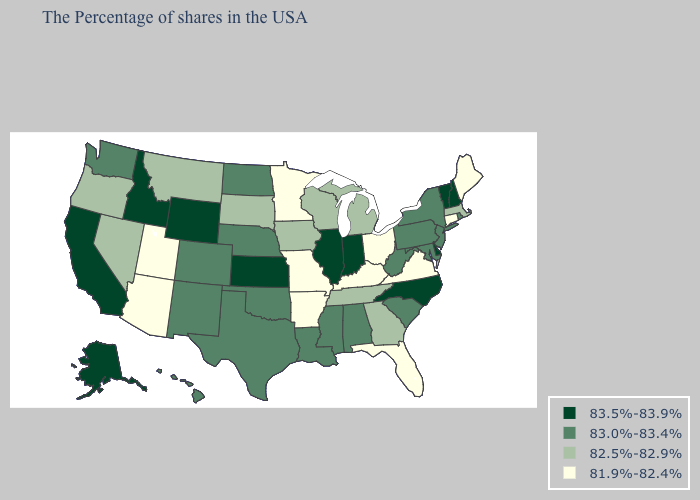How many symbols are there in the legend?
Write a very short answer. 4. Name the states that have a value in the range 83.5%-83.9%?
Be succinct. New Hampshire, Vermont, Delaware, North Carolina, Indiana, Illinois, Kansas, Wyoming, Idaho, California, Alaska. Name the states that have a value in the range 82.5%-82.9%?
Short answer required. Massachusetts, Georgia, Michigan, Tennessee, Wisconsin, Iowa, South Dakota, Montana, Nevada, Oregon. What is the highest value in the MidWest ?
Concise answer only. 83.5%-83.9%. Which states have the highest value in the USA?
Write a very short answer. New Hampshire, Vermont, Delaware, North Carolina, Indiana, Illinois, Kansas, Wyoming, Idaho, California, Alaska. Name the states that have a value in the range 83.5%-83.9%?
Concise answer only. New Hampshire, Vermont, Delaware, North Carolina, Indiana, Illinois, Kansas, Wyoming, Idaho, California, Alaska. Name the states that have a value in the range 83.5%-83.9%?
Short answer required. New Hampshire, Vermont, Delaware, North Carolina, Indiana, Illinois, Kansas, Wyoming, Idaho, California, Alaska. What is the value of Idaho?
Give a very brief answer. 83.5%-83.9%. Does New York have a lower value than Wyoming?
Be succinct. Yes. Does Tennessee have the lowest value in the South?
Keep it brief. No. Does Alaska have a lower value than Utah?
Be succinct. No. Does North Carolina have the lowest value in the South?
Keep it brief. No. Name the states that have a value in the range 81.9%-82.4%?
Short answer required. Maine, Connecticut, Virginia, Ohio, Florida, Kentucky, Missouri, Arkansas, Minnesota, Utah, Arizona. Which states have the lowest value in the MidWest?
Quick response, please. Ohio, Missouri, Minnesota. What is the value of Maine?
Write a very short answer. 81.9%-82.4%. 